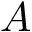Convert formula to latex. <formula><loc_0><loc_0><loc_500><loc_500>A</formula> 